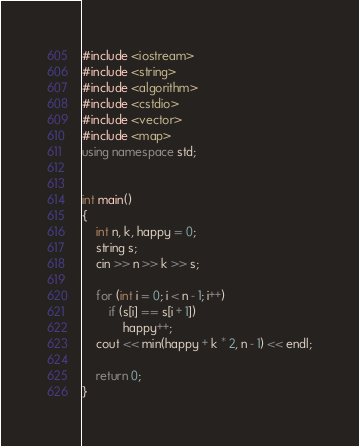<code> <loc_0><loc_0><loc_500><loc_500><_C++_>#include <iostream>
#include <string>
#include <algorithm>
#include <cstdio>
#include <vector>
#include <map>
using namespace std;


int main() 
{
	int n, k, happy = 0;
	string s;
	cin >> n >> k >> s;

	for (int i = 0; i < n - 1; i++)
		if (s[i] == s[i + 1])
			happy++;
	cout << min(happy + k * 2, n - 1) << endl;

	return 0;
}</code> 